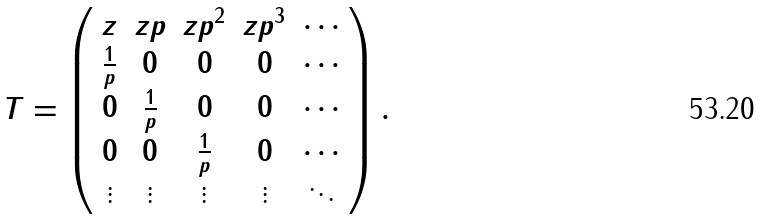Convert formula to latex. <formula><loc_0><loc_0><loc_500><loc_500>T = \left ( \begin{array} { c c c c c } z & z p & z p ^ { 2 } & z p ^ { 3 } & \cdots \\ \frac { 1 } { p } & 0 & 0 & 0 & \cdots \\ 0 & \frac { 1 } { p } & 0 & 0 & \cdots \\ 0 & 0 & \frac { 1 } { p } & 0 & \cdots \\ \vdots & \vdots & \vdots & \vdots & \ddots \end{array} \right ) .</formula> 